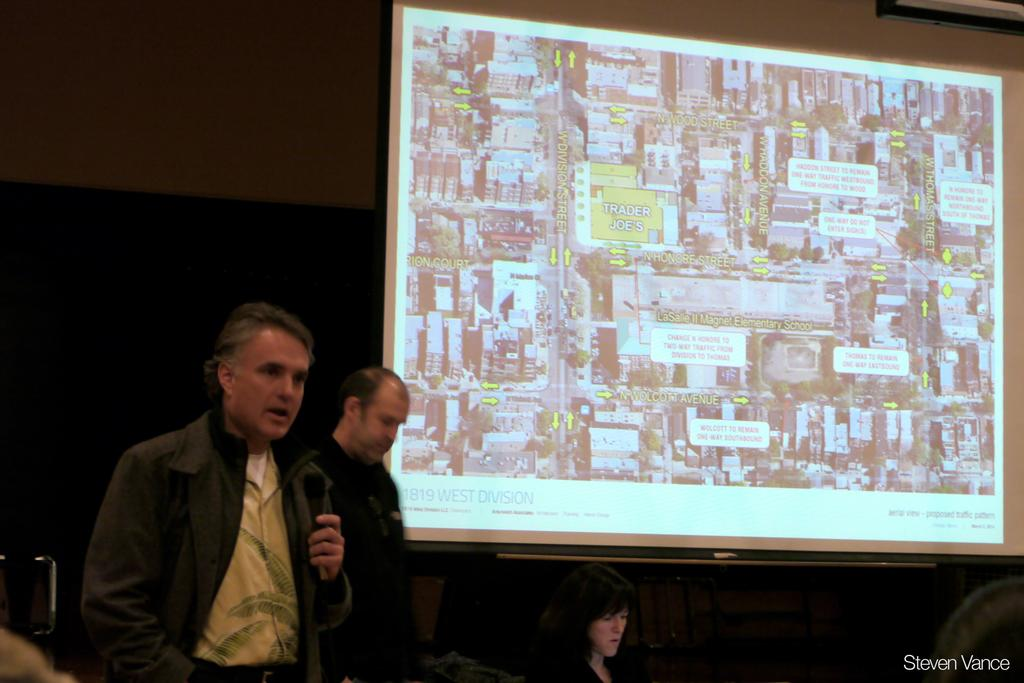What is one of the main features in the image? There is a wall in the image. What else can be seen in the image? There is a screen and people in the image. Can you describe the man on the left side of the image? The man is standing on the left side of the image, wearing a black color jacket, and holding a mic. How would you describe the lighting in the image? The image is a little dark. What type of shirt is the judge wearing in the image? There is no judge present in the image, and therefore no shirt to describe. How much butter is visible on the screen in the image? There is no butter present in the image, and the screen is not related to any food items. 